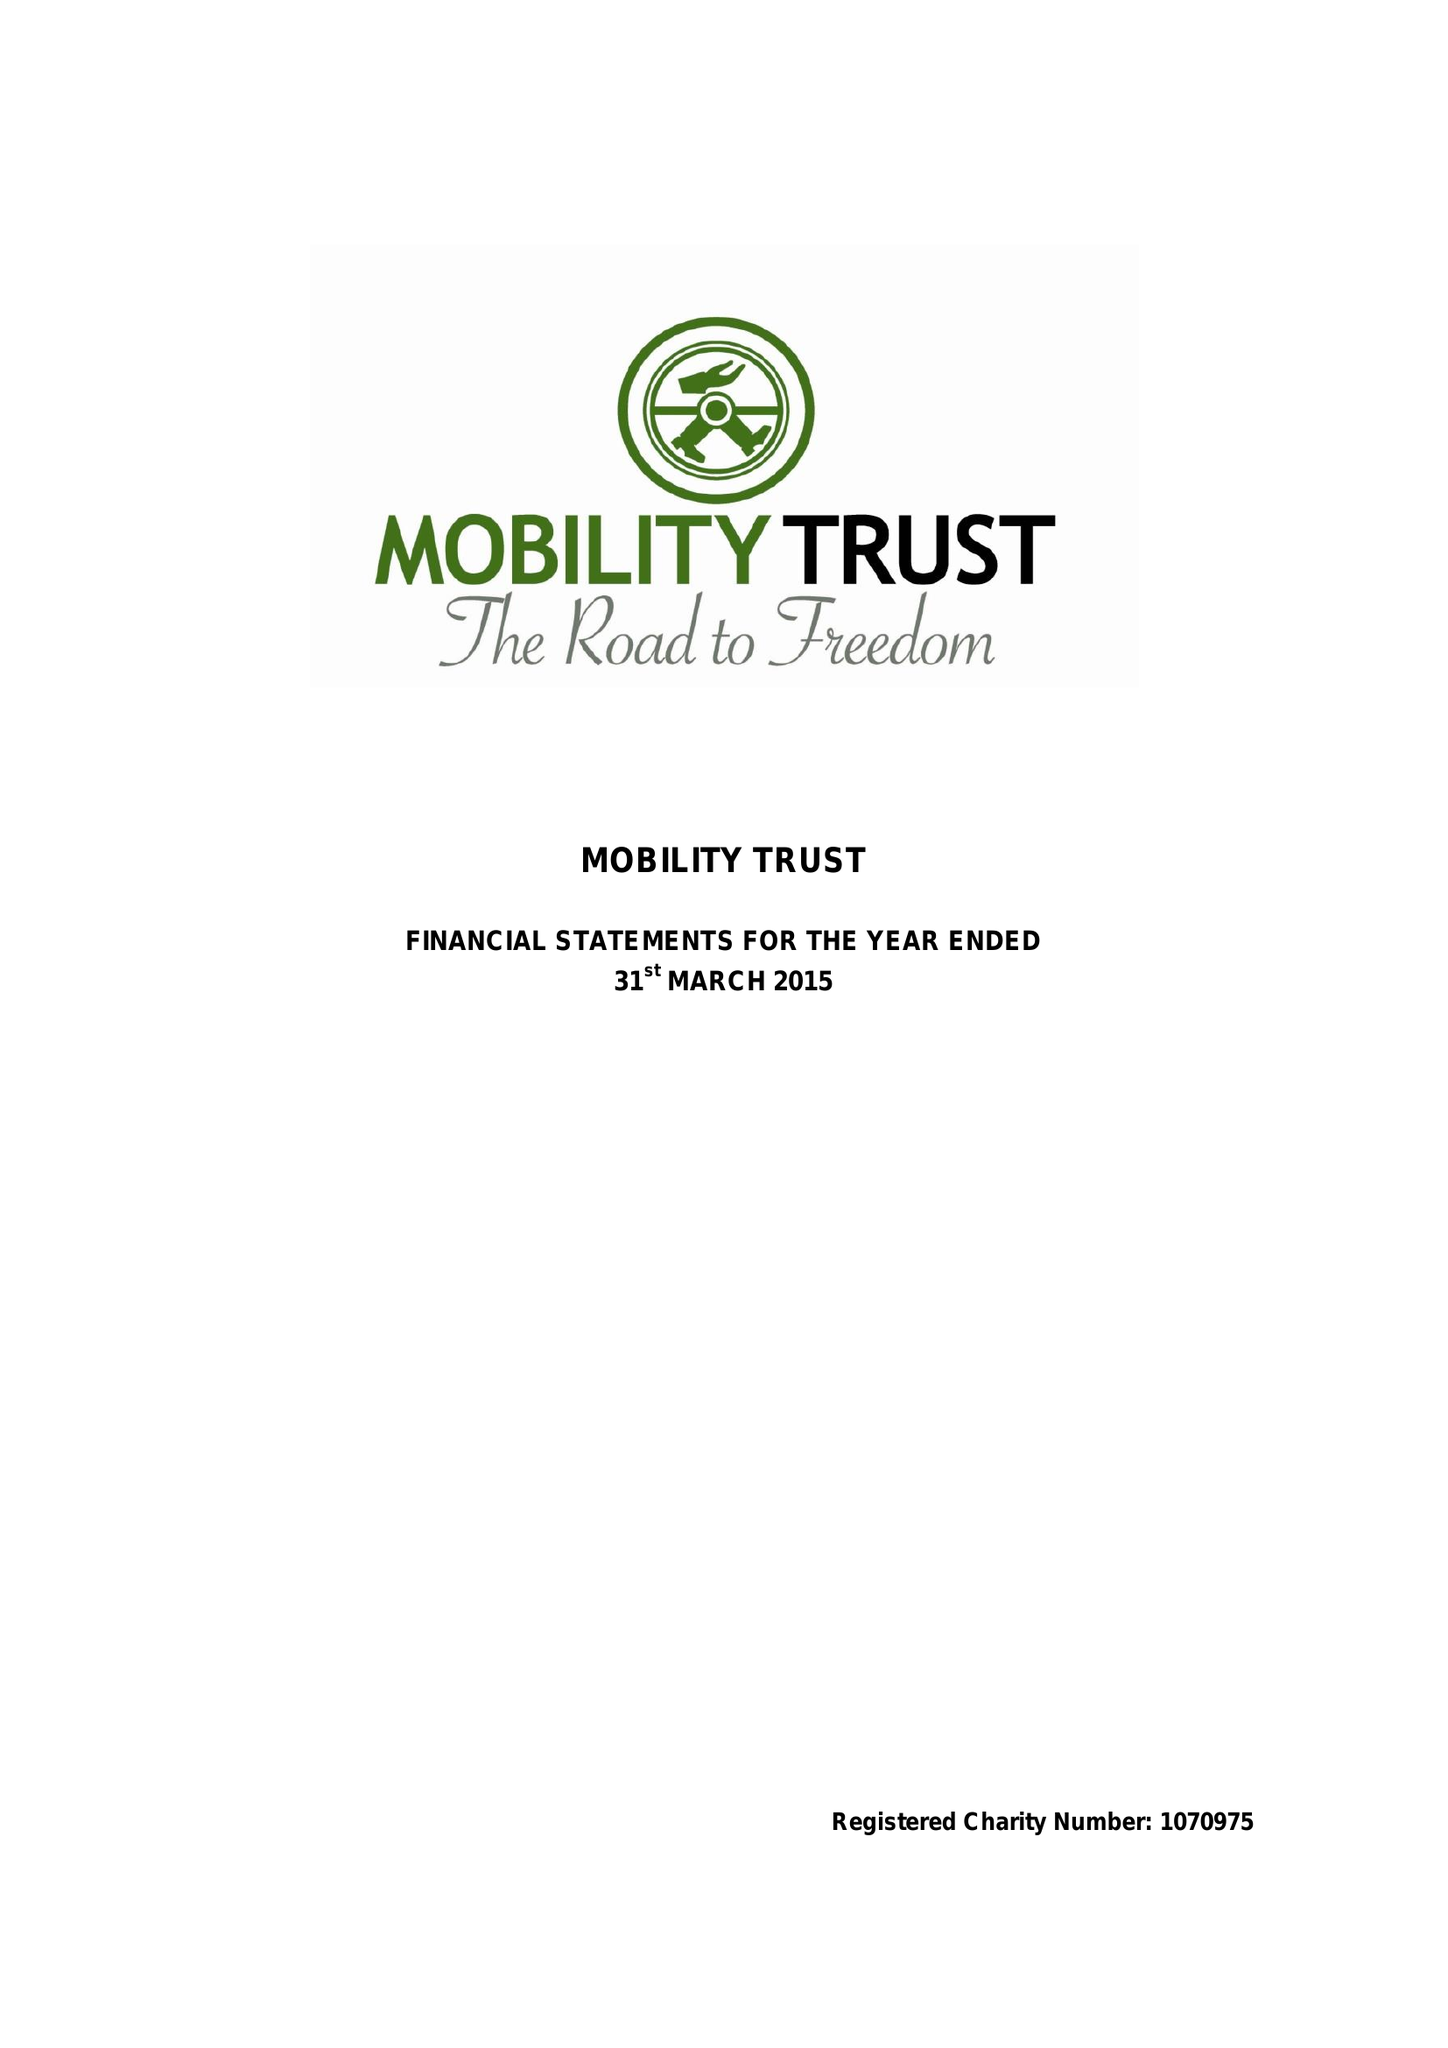What is the value for the report_date?
Answer the question using a single word or phrase. 2015-03-31 